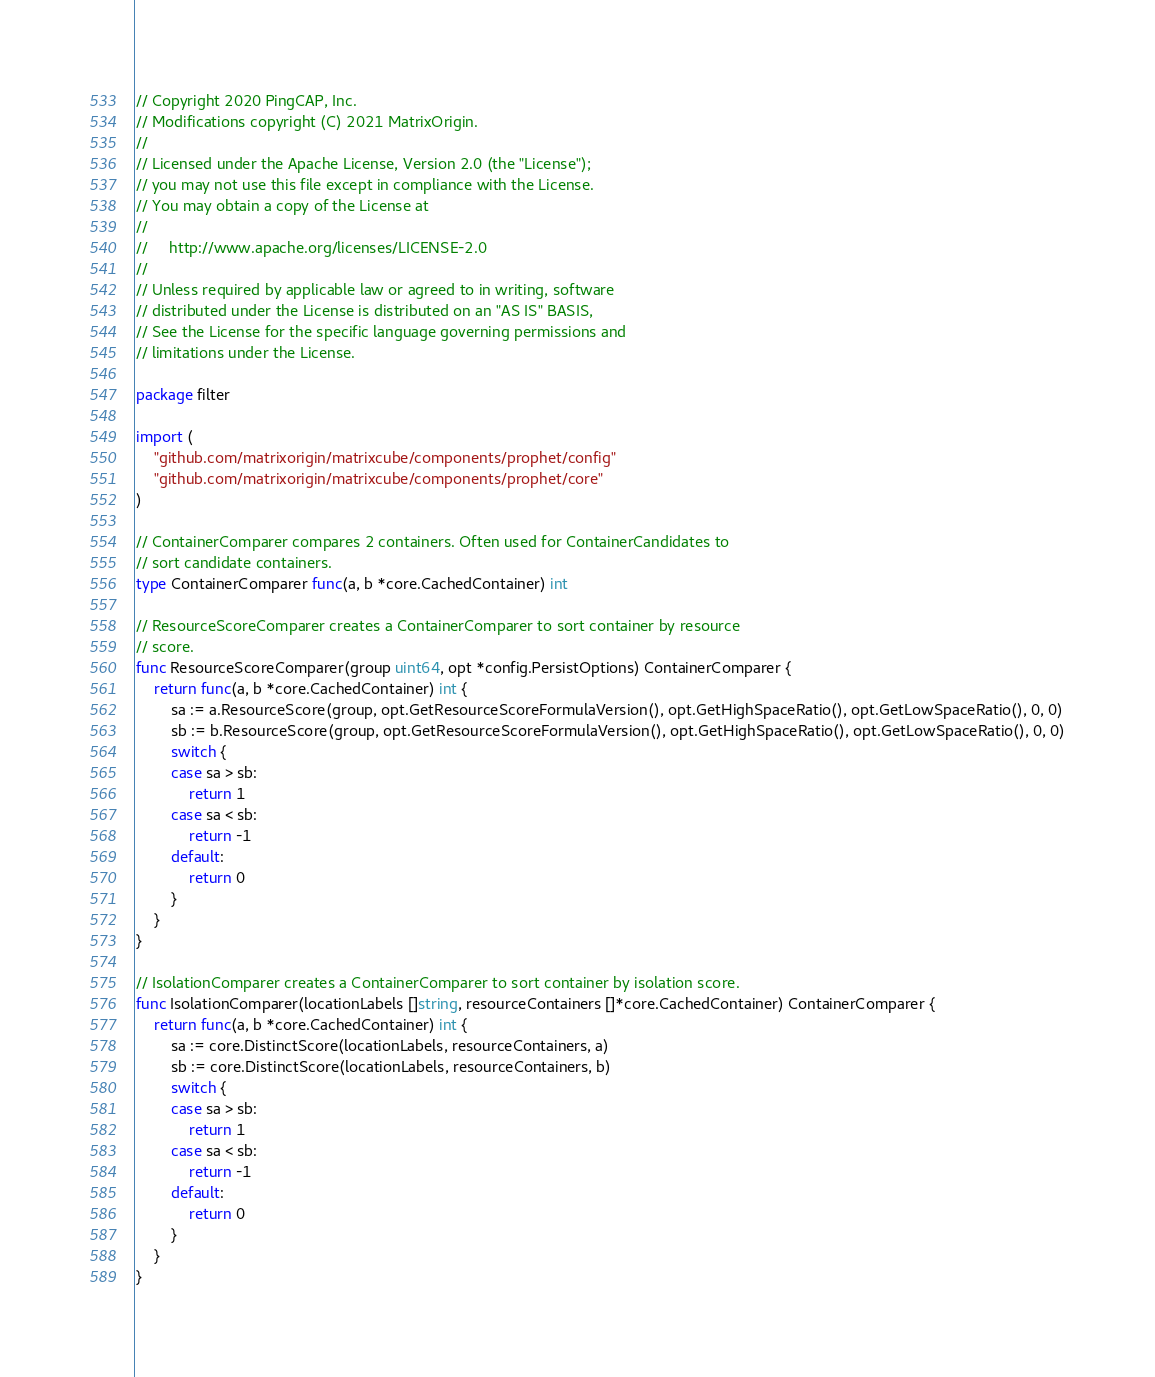Convert code to text. <code><loc_0><loc_0><loc_500><loc_500><_Go_>// Copyright 2020 PingCAP, Inc.
// Modifications copyright (C) 2021 MatrixOrigin.
//
// Licensed under the Apache License, Version 2.0 (the "License");
// you may not use this file except in compliance with the License.
// You may obtain a copy of the License at
//
//     http://www.apache.org/licenses/LICENSE-2.0
//
// Unless required by applicable law or agreed to in writing, software
// distributed under the License is distributed on an "AS IS" BASIS,
// See the License for the specific language governing permissions and
// limitations under the License.

package filter

import (
	"github.com/matrixorigin/matrixcube/components/prophet/config"
	"github.com/matrixorigin/matrixcube/components/prophet/core"
)

// ContainerComparer compares 2 containers. Often used for ContainerCandidates to
// sort candidate containers.
type ContainerComparer func(a, b *core.CachedContainer) int

// ResourceScoreComparer creates a ContainerComparer to sort container by resource
// score.
func ResourceScoreComparer(group uint64, opt *config.PersistOptions) ContainerComparer {
	return func(a, b *core.CachedContainer) int {
		sa := a.ResourceScore(group, opt.GetResourceScoreFormulaVersion(), opt.GetHighSpaceRatio(), opt.GetLowSpaceRatio(), 0, 0)
		sb := b.ResourceScore(group, opt.GetResourceScoreFormulaVersion(), opt.GetHighSpaceRatio(), opt.GetLowSpaceRatio(), 0, 0)
		switch {
		case sa > sb:
			return 1
		case sa < sb:
			return -1
		default:
			return 0
		}
	}
}

// IsolationComparer creates a ContainerComparer to sort container by isolation score.
func IsolationComparer(locationLabels []string, resourceContainers []*core.CachedContainer) ContainerComparer {
	return func(a, b *core.CachedContainer) int {
		sa := core.DistinctScore(locationLabels, resourceContainers, a)
		sb := core.DistinctScore(locationLabels, resourceContainers, b)
		switch {
		case sa > sb:
			return 1
		case sa < sb:
			return -1
		default:
			return 0
		}
	}
}
</code> 